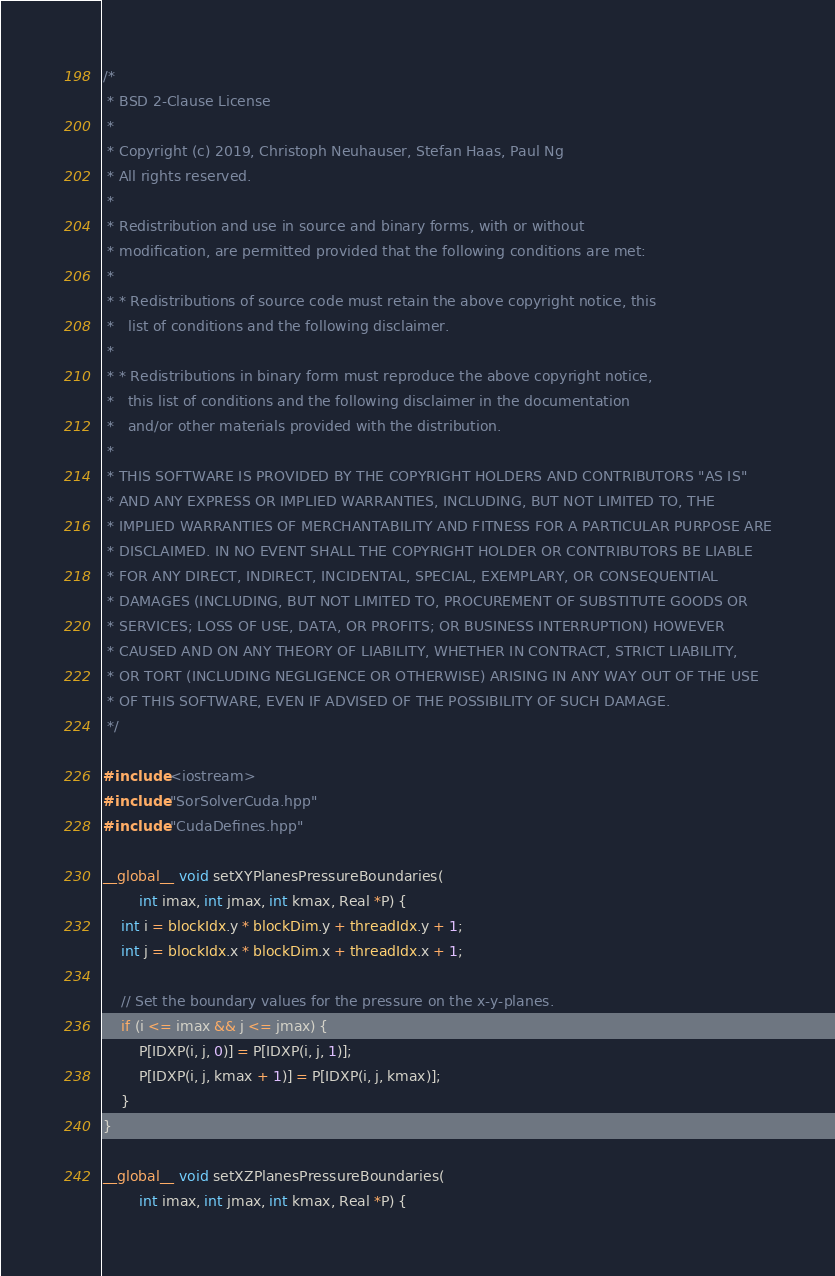Convert code to text. <code><loc_0><loc_0><loc_500><loc_500><_Cuda_>/*
 * BSD 2-Clause License
 *
 * Copyright (c) 2019, Christoph Neuhauser, Stefan Haas, Paul Ng
 * All rights reserved.
 *
 * Redistribution and use in source and binary forms, with or without
 * modification, are permitted provided that the following conditions are met:
 *
 * * Redistributions of source code must retain the above copyright notice, this
 *   list of conditions and the following disclaimer.
 *
 * * Redistributions in binary form must reproduce the above copyright notice,
 *   this list of conditions and the following disclaimer in the documentation
 *   and/or other materials provided with the distribution.
 *
 * THIS SOFTWARE IS PROVIDED BY THE COPYRIGHT HOLDERS AND CONTRIBUTORS "AS IS"
 * AND ANY EXPRESS OR IMPLIED WARRANTIES, INCLUDING, BUT NOT LIMITED TO, THE
 * IMPLIED WARRANTIES OF MERCHANTABILITY AND FITNESS FOR A PARTICULAR PURPOSE ARE
 * DISCLAIMED. IN NO EVENT SHALL THE COPYRIGHT HOLDER OR CONTRIBUTORS BE LIABLE
 * FOR ANY DIRECT, INDIRECT, INCIDENTAL, SPECIAL, EXEMPLARY, OR CONSEQUENTIAL
 * DAMAGES (INCLUDING, BUT NOT LIMITED TO, PROCUREMENT OF SUBSTITUTE GOODS OR
 * SERVICES; LOSS OF USE, DATA, OR PROFITS; OR BUSINESS INTERRUPTION) HOWEVER
 * CAUSED AND ON ANY THEORY OF LIABILITY, WHETHER IN CONTRACT, STRICT LIABILITY,
 * OR TORT (INCLUDING NEGLIGENCE OR OTHERWISE) ARISING IN ANY WAY OUT OF THE USE
 * OF THIS SOFTWARE, EVEN IF ADVISED OF THE POSSIBILITY OF SUCH DAMAGE.
 */

#include <iostream>
#include "SorSolverCuda.hpp"
#include "CudaDefines.hpp"

__global__ void setXYPlanesPressureBoundaries(
        int imax, int jmax, int kmax, Real *P) {
    int i = blockIdx.y * blockDim.y + threadIdx.y + 1;
    int j = blockIdx.x * blockDim.x + threadIdx.x + 1;

    // Set the boundary values for the pressure on the x-y-planes.
    if (i <= imax && j <= jmax) {
        P[IDXP(i, j, 0)] = P[IDXP(i, j, 1)];
        P[IDXP(i, j, kmax + 1)] = P[IDXP(i, j, kmax)];
    }
}

__global__ void setXZPlanesPressureBoundaries(
        int imax, int jmax, int kmax, Real *P) {</code> 